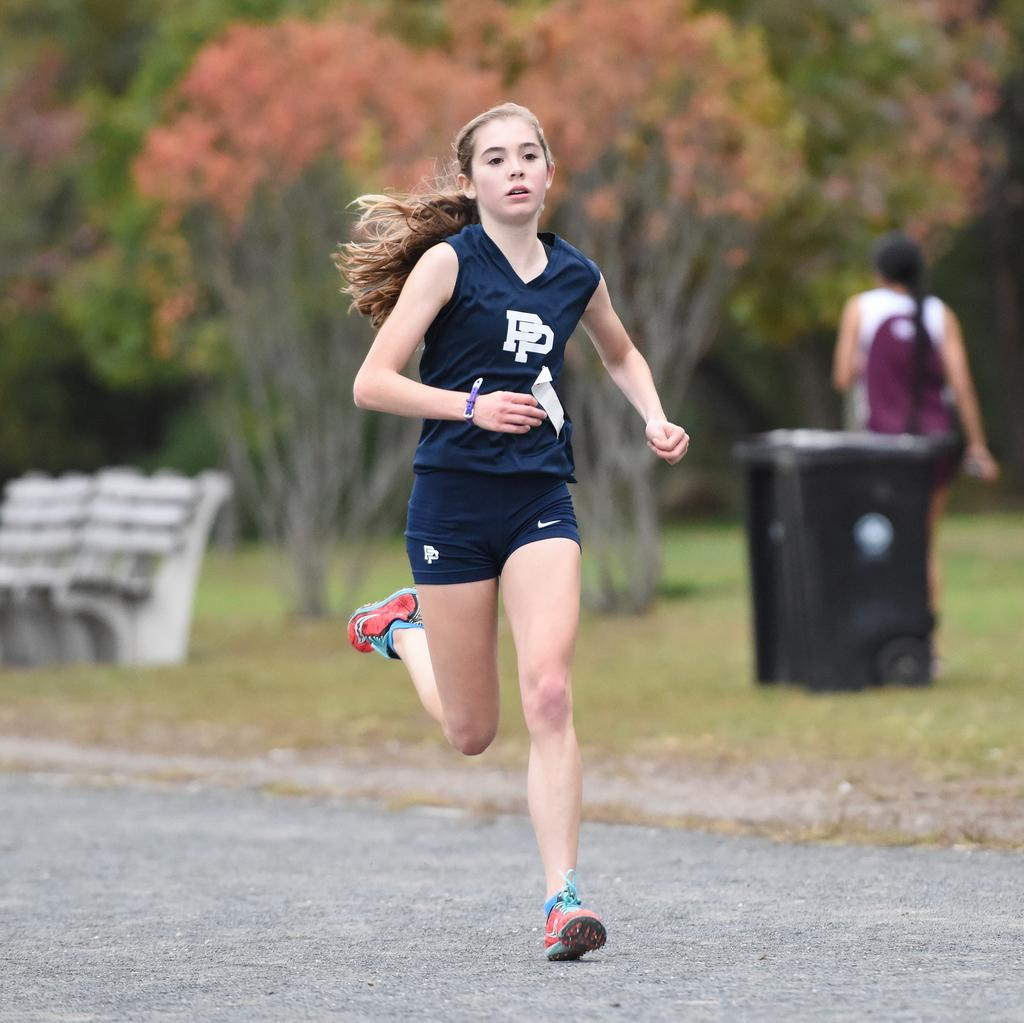What is the girl in the foreground of the image doing? The girl is running in the foreground of the image. Where is the girl running? The girl is running on the road. What can be seen in the background of the image? There are trees, a bench, and a black color object in the background of the image. What is the woman in the background of the image doing? The woman is walking on the grass in the background of the image. What type of dirt can be seen on the road where the girl is running? There is no dirt visible on the road where the girl is running; the road appears to be clean. Is there a bed present in the image? No, there is no bed present in the image. 